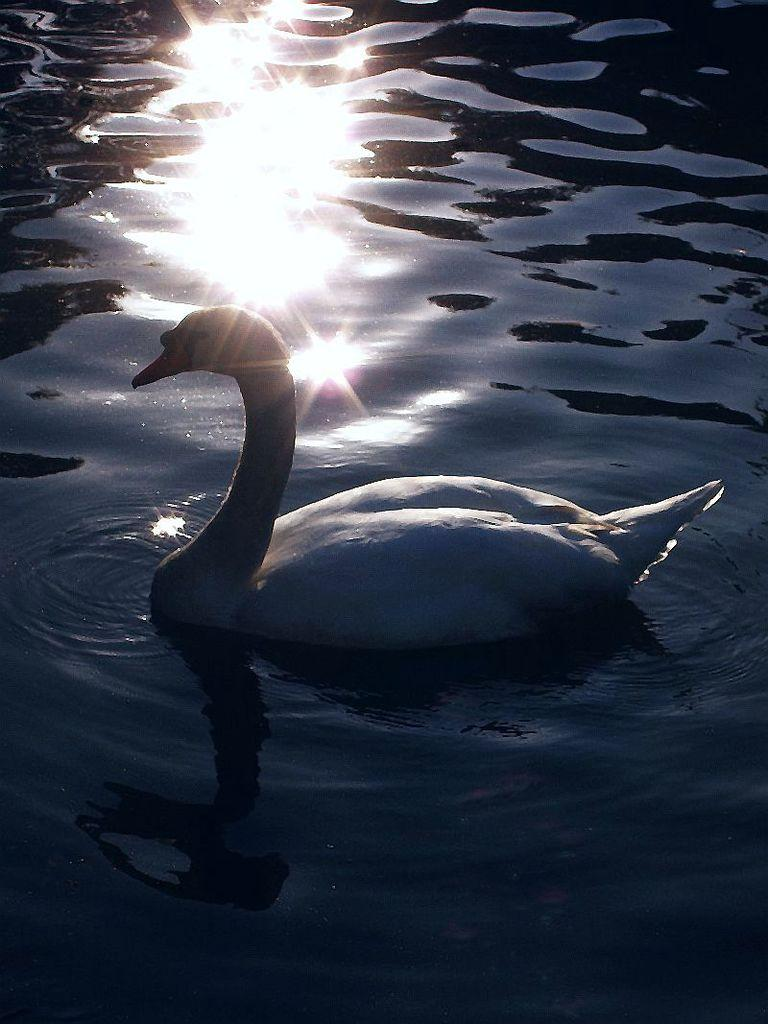What is the primary element visible in the image? There is water in the image. What type of animal can be seen in the water? There is a white-colored swan in the image. Where is the swan positioned in the image? The swan is in the front of the image. What historical event is being commemorated by the swan in the image? There is no indication of a historical event or commemoration in the image; it simply features a swan in the water. What type of tools might a carpenter use in the image? There are no carpentry tools or a carpenter present in the image. Is the swan reading a book in the image? No, the swan is not reading a book in the image; it is simply swimming in the water. 